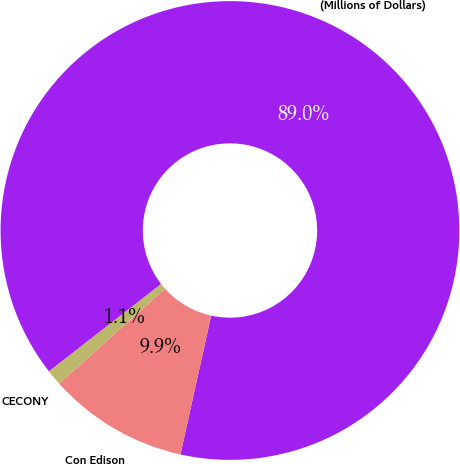<chart> <loc_0><loc_0><loc_500><loc_500><pie_chart><fcel>(Millions of Dollars)<fcel>Con Edison<fcel>CECONY<nl><fcel>89.0%<fcel>9.9%<fcel>1.11%<nl></chart> 